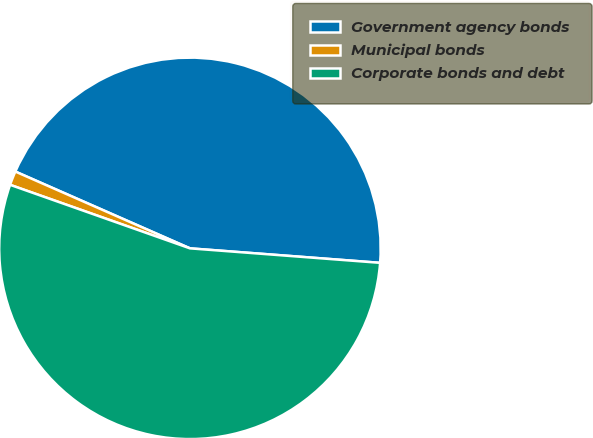Convert chart to OTSL. <chart><loc_0><loc_0><loc_500><loc_500><pie_chart><fcel>Government agency bonds<fcel>Municipal bonds<fcel>Corporate bonds and debt<nl><fcel>44.62%<fcel>1.19%<fcel>54.2%<nl></chart> 